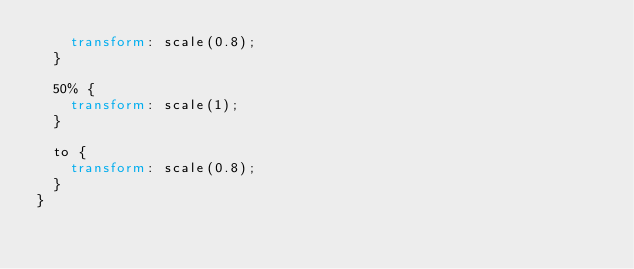<code> <loc_0><loc_0><loc_500><loc_500><_CSS_>    transform: scale(0.8);
  }

  50% {
    transform: scale(1);
  }

  to {
    transform: scale(0.8);
  }
}
</code> 